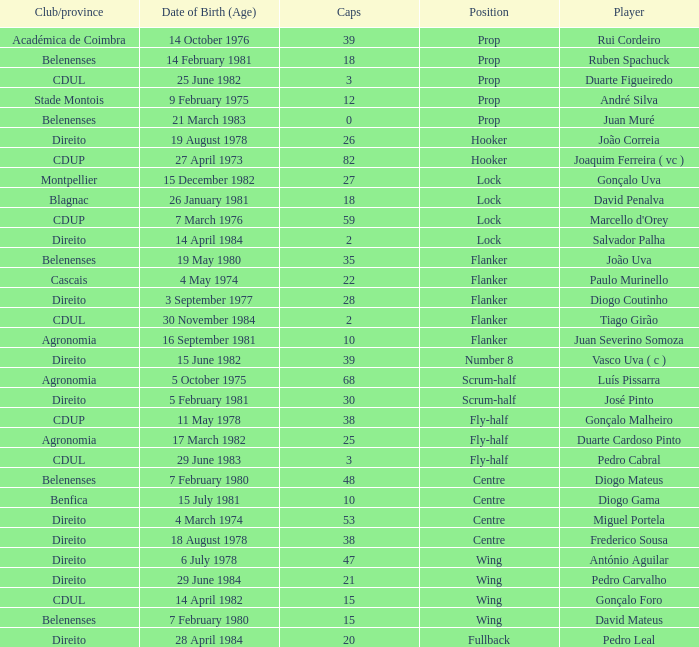Which player has a Club/province of direito, less than 21 caps, and a Position of lock? Salvador Palha. 